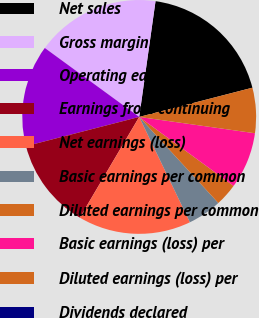Convert chart to OTSL. <chart><loc_0><loc_0><loc_500><loc_500><pie_chart><fcel>Net sales<fcel>Gross margin<fcel>Operating earnings<fcel>Earnings from continuing<fcel>Net earnings (loss)<fcel>Basic earnings per common<fcel>Diluted earnings per common<fcel>Basic earnings (loss) per<fcel>Diluted earnings (loss) per<fcel>Dividends declared<nl><fcel>18.75%<fcel>17.19%<fcel>14.06%<fcel>12.5%<fcel>15.62%<fcel>4.69%<fcel>3.13%<fcel>7.81%<fcel>6.25%<fcel>0.0%<nl></chart> 